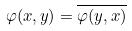Convert formula to latex. <formula><loc_0><loc_0><loc_500><loc_500>\varphi ( x , y ) = \overline { \varphi ( y , x ) }</formula> 